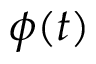Convert formula to latex. <formula><loc_0><loc_0><loc_500><loc_500>\phi ( t )</formula> 